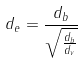<formula> <loc_0><loc_0><loc_500><loc_500>d _ { e } = \frac { d _ { b } } { \sqrt { \frac { d _ { b } } { d _ { v } } } }</formula> 